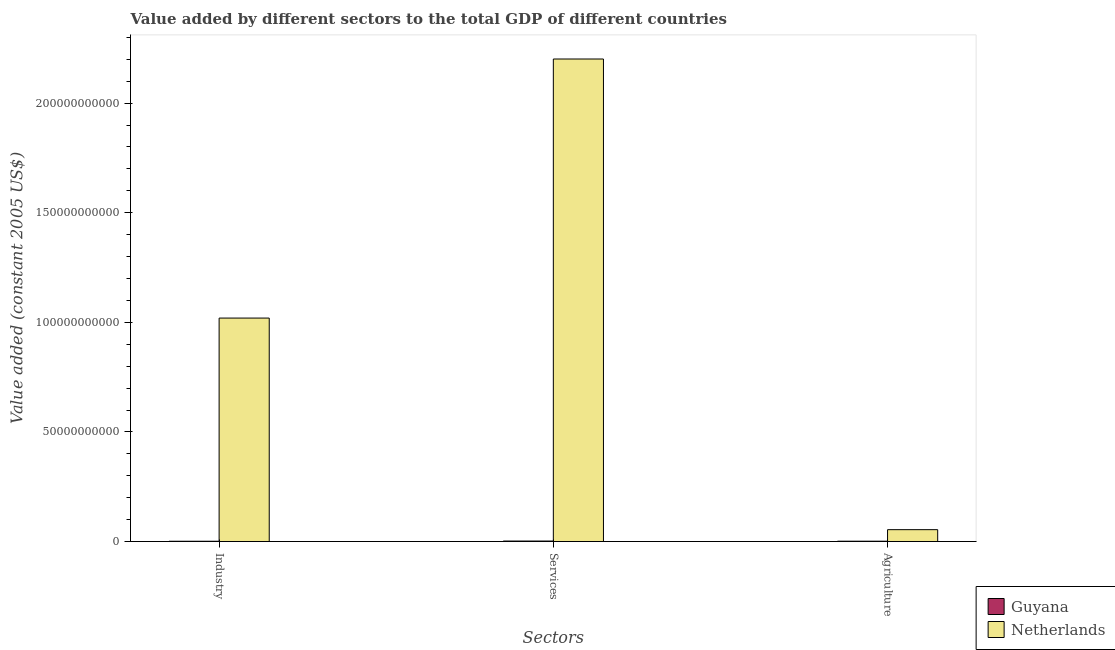How many different coloured bars are there?
Keep it short and to the point. 2. How many groups of bars are there?
Give a very brief answer. 3. Are the number of bars per tick equal to the number of legend labels?
Your response must be concise. Yes. How many bars are there on the 3rd tick from the left?
Offer a terse response. 2. How many bars are there on the 2nd tick from the right?
Keep it short and to the point. 2. What is the label of the 3rd group of bars from the left?
Provide a succinct answer. Agriculture. What is the value added by agricultural sector in Netherlands?
Keep it short and to the point. 5.43e+09. Across all countries, what is the maximum value added by services?
Your answer should be compact. 2.20e+11. Across all countries, what is the minimum value added by agricultural sector?
Your response must be concise. 1.65e+08. In which country was the value added by industrial sector minimum?
Provide a short and direct response. Guyana. What is the total value added by services in the graph?
Your response must be concise. 2.20e+11. What is the difference between the value added by agricultural sector in Netherlands and that in Guyana?
Your answer should be compact. 5.26e+09. What is the difference between the value added by agricultural sector in Guyana and the value added by industrial sector in Netherlands?
Offer a very short reply. -1.02e+11. What is the average value added by services per country?
Your answer should be very brief. 1.10e+11. What is the difference between the value added by industrial sector and value added by services in Netherlands?
Your answer should be very brief. -1.18e+11. In how many countries, is the value added by industrial sector greater than 180000000000 US$?
Your response must be concise. 0. What is the ratio of the value added by agricultural sector in Guyana to that in Netherlands?
Make the answer very short. 0.03. Is the value added by industrial sector in Netherlands less than that in Guyana?
Give a very brief answer. No. What is the difference between the highest and the second highest value added by industrial sector?
Ensure brevity in your answer.  1.02e+11. What is the difference between the highest and the lowest value added by services?
Your response must be concise. 2.20e+11. In how many countries, is the value added by services greater than the average value added by services taken over all countries?
Your answer should be very brief. 1. Is the sum of the value added by agricultural sector in Guyana and Netherlands greater than the maximum value added by services across all countries?
Keep it short and to the point. No. What does the 2nd bar from the right in Industry represents?
Offer a very short reply. Guyana. Is it the case that in every country, the sum of the value added by industrial sector and value added by services is greater than the value added by agricultural sector?
Make the answer very short. Yes. How many bars are there?
Your response must be concise. 6. Are all the bars in the graph horizontal?
Ensure brevity in your answer.  No. How many countries are there in the graph?
Keep it short and to the point. 2. Are the values on the major ticks of Y-axis written in scientific E-notation?
Your answer should be very brief. No. How many legend labels are there?
Your response must be concise. 2. What is the title of the graph?
Give a very brief answer. Value added by different sectors to the total GDP of different countries. Does "Central Europe" appear as one of the legend labels in the graph?
Your response must be concise. No. What is the label or title of the X-axis?
Make the answer very short. Sectors. What is the label or title of the Y-axis?
Ensure brevity in your answer.  Value added (constant 2005 US$). What is the Value added (constant 2005 US$) in Guyana in Industry?
Offer a very short reply. 1.43e+08. What is the Value added (constant 2005 US$) in Netherlands in Industry?
Make the answer very short. 1.02e+11. What is the Value added (constant 2005 US$) of Guyana in Services?
Offer a very short reply. 2.38e+08. What is the Value added (constant 2005 US$) in Netherlands in Services?
Provide a short and direct response. 2.20e+11. What is the Value added (constant 2005 US$) of Guyana in Agriculture?
Make the answer very short. 1.65e+08. What is the Value added (constant 2005 US$) of Netherlands in Agriculture?
Your answer should be compact. 5.43e+09. Across all Sectors, what is the maximum Value added (constant 2005 US$) in Guyana?
Keep it short and to the point. 2.38e+08. Across all Sectors, what is the maximum Value added (constant 2005 US$) in Netherlands?
Make the answer very short. 2.20e+11. Across all Sectors, what is the minimum Value added (constant 2005 US$) of Guyana?
Give a very brief answer. 1.43e+08. Across all Sectors, what is the minimum Value added (constant 2005 US$) of Netherlands?
Offer a terse response. 5.43e+09. What is the total Value added (constant 2005 US$) of Guyana in the graph?
Your answer should be compact. 5.47e+08. What is the total Value added (constant 2005 US$) in Netherlands in the graph?
Ensure brevity in your answer.  3.27e+11. What is the difference between the Value added (constant 2005 US$) in Guyana in Industry and that in Services?
Keep it short and to the point. -9.47e+07. What is the difference between the Value added (constant 2005 US$) of Netherlands in Industry and that in Services?
Your response must be concise. -1.18e+11. What is the difference between the Value added (constant 2005 US$) of Guyana in Industry and that in Agriculture?
Your response must be concise. -2.19e+07. What is the difference between the Value added (constant 2005 US$) of Netherlands in Industry and that in Agriculture?
Your response must be concise. 9.65e+1. What is the difference between the Value added (constant 2005 US$) in Guyana in Services and that in Agriculture?
Make the answer very short. 7.28e+07. What is the difference between the Value added (constant 2005 US$) of Netherlands in Services and that in Agriculture?
Provide a succinct answer. 2.15e+11. What is the difference between the Value added (constant 2005 US$) of Guyana in Industry and the Value added (constant 2005 US$) of Netherlands in Services?
Keep it short and to the point. -2.20e+11. What is the difference between the Value added (constant 2005 US$) in Guyana in Industry and the Value added (constant 2005 US$) in Netherlands in Agriculture?
Offer a terse response. -5.28e+09. What is the difference between the Value added (constant 2005 US$) of Guyana in Services and the Value added (constant 2005 US$) of Netherlands in Agriculture?
Give a very brief answer. -5.19e+09. What is the average Value added (constant 2005 US$) in Guyana per Sectors?
Ensure brevity in your answer.  1.82e+08. What is the average Value added (constant 2005 US$) in Netherlands per Sectors?
Keep it short and to the point. 1.09e+11. What is the difference between the Value added (constant 2005 US$) in Guyana and Value added (constant 2005 US$) in Netherlands in Industry?
Make the answer very short. -1.02e+11. What is the difference between the Value added (constant 2005 US$) of Guyana and Value added (constant 2005 US$) of Netherlands in Services?
Offer a very short reply. -2.20e+11. What is the difference between the Value added (constant 2005 US$) of Guyana and Value added (constant 2005 US$) of Netherlands in Agriculture?
Provide a short and direct response. -5.26e+09. What is the ratio of the Value added (constant 2005 US$) of Guyana in Industry to that in Services?
Ensure brevity in your answer.  0.6. What is the ratio of the Value added (constant 2005 US$) of Netherlands in Industry to that in Services?
Provide a succinct answer. 0.46. What is the ratio of the Value added (constant 2005 US$) in Guyana in Industry to that in Agriculture?
Offer a very short reply. 0.87. What is the ratio of the Value added (constant 2005 US$) in Netherlands in Industry to that in Agriculture?
Provide a succinct answer. 18.78. What is the ratio of the Value added (constant 2005 US$) in Guyana in Services to that in Agriculture?
Keep it short and to the point. 1.44. What is the ratio of the Value added (constant 2005 US$) in Netherlands in Services to that in Agriculture?
Provide a succinct answer. 40.55. What is the difference between the highest and the second highest Value added (constant 2005 US$) in Guyana?
Ensure brevity in your answer.  7.28e+07. What is the difference between the highest and the second highest Value added (constant 2005 US$) of Netherlands?
Your answer should be very brief. 1.18e+11. What is the difference between the highest and the lowest Value added (constant 2005 US$) of Guyana?
Make the answer very short. 9.47e+07. What is the difference between the highest and the lowest Value added (constant 2005 US$) of Netherlands?
Offer a terse response. 2.15e+11. 